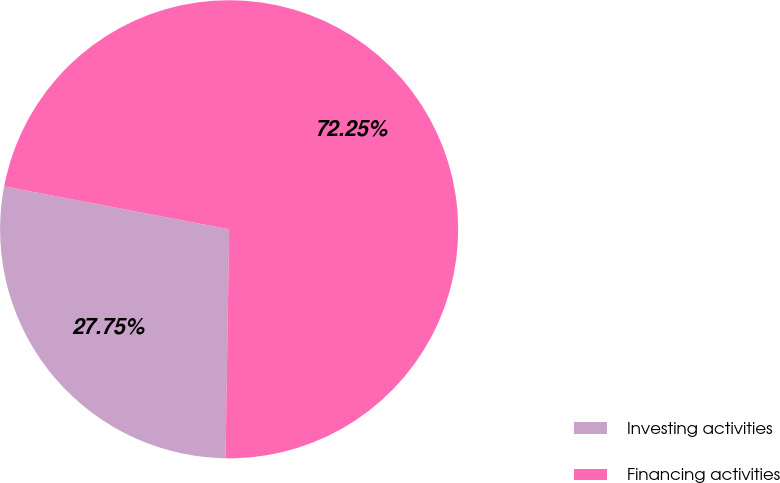<chart> <loc_0><loc_0><loc_500><loc_500><pie_chart><fcel>Investing activities<fcel>Financing activities<nl><fcel>27.75%<fcel>72.25%<nl></chart> 